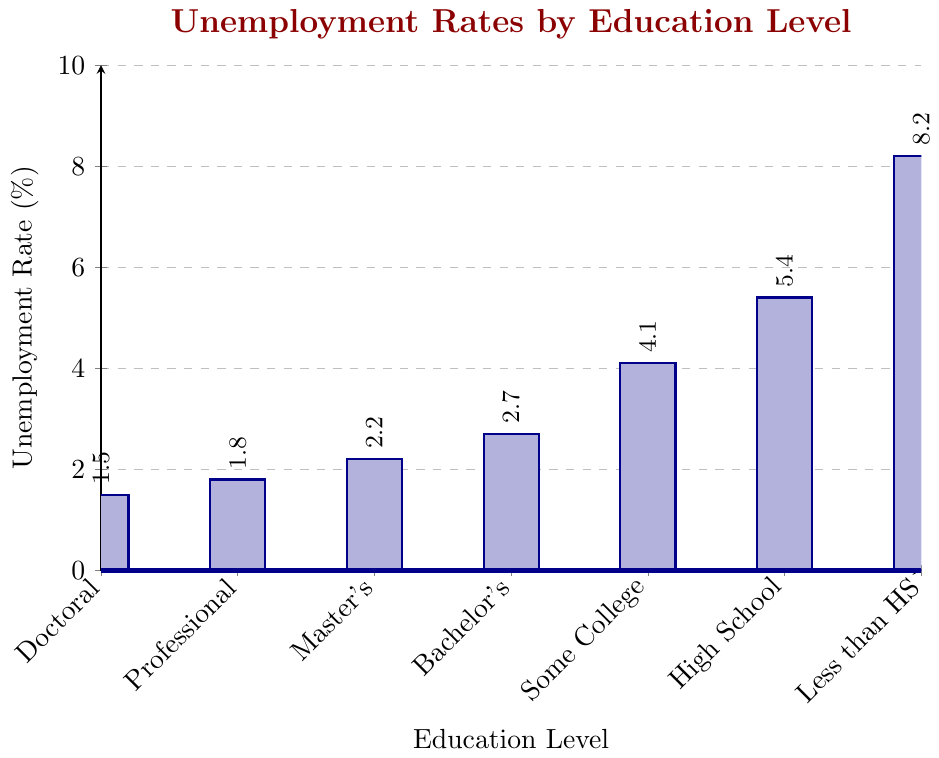Which education level has the highest unemployment rate? The bar for "Less than High School" is the highest in the chart, indicating that it has the highest unemployment rate.
Answer: Less than High School Which education level has the lowest unemployment rate? The bar for "Doctoral Degree" is the lowest in the chart, indicating that it has the lowest unemployment rate.
Answer: Doctoral Degree What is the difference in unemployment rate between high school graduates and bachelor's degree holders? The rate for "High School Graduate" is 5.4%, and the rate for "Bachelor's Degree" is 2.7%. The difference is 5.4% - 2.7% = 2.7%.
Answer: 2.7% Which education level falls under a 3% unemployment rate but higher than 2%? The unemployment rates that fit are for "Bachelor's Degree" (2.7%) and "Master's Degree" (2.2%), but only "Bachelor's Degree" is above 2%.
Answer: Bachelor's Degree What is the approximate average unemployment rate across all education levels mentioned? Summing the rates: 8.2 + 5.4 + 4.1 + 2.7 + 2.2 + 1.8 + 1.5 = 25.9. There are 7 categories, so average = 25.9 / 7 ≈ 3.7%.
Answer: 3.7% Compare the unemployment rates of "Some College or Associate Degree" and "Master's Degree". Which one is higher and by how much? The rate for "Some College or Associate Degree" is 4.1%, and the rate for "Master's Degree" is 2.2%. The difference is 4.1% - 2.2% = 1.9%. "Some College or Associate Degree" is higher by 1.9%.
Answer: 1.9% How many education levels have an unemployment rate lower than the overall average rate calculated above? The average rate is approximately 3.7%. The categories with rates below this are "Bachelor's Degree", "Master's Degree", "Professional Degree", and "Doctoral Degree". There are 4 such categories.
Answer: 4 What is the total unemployment rate for "Professional Degree" and "Doctoral Degree" combined? The rate for "Professional Degree" is 1.8%, and the rate for "Doctoral Degree" is 1.5%. Combined, the total rate is 1.8% + 1.5% = 3.3%.
Answer: 3.3% Is the unemployment rate for "High School Graduate" greater than twice that of "Doctoral Degree"? The rate for "High School Graduate" is 5.4%, and twice the rate of "Doctoral Degree" (1.5%) is 3.0%. Since 5.4% is more than 3.0%, the statement is true.
Answer: Yes What is the ratio of unemployment rates between "Bachelor's Degree" and "Less than High School"? The rate for "Bachelor's Degree" is 2.7%, and the rate for "Less than High School" is 8.2%. The ratio is 2.7% / 8.2% ≈ 0.33.
Answer: 0.33 